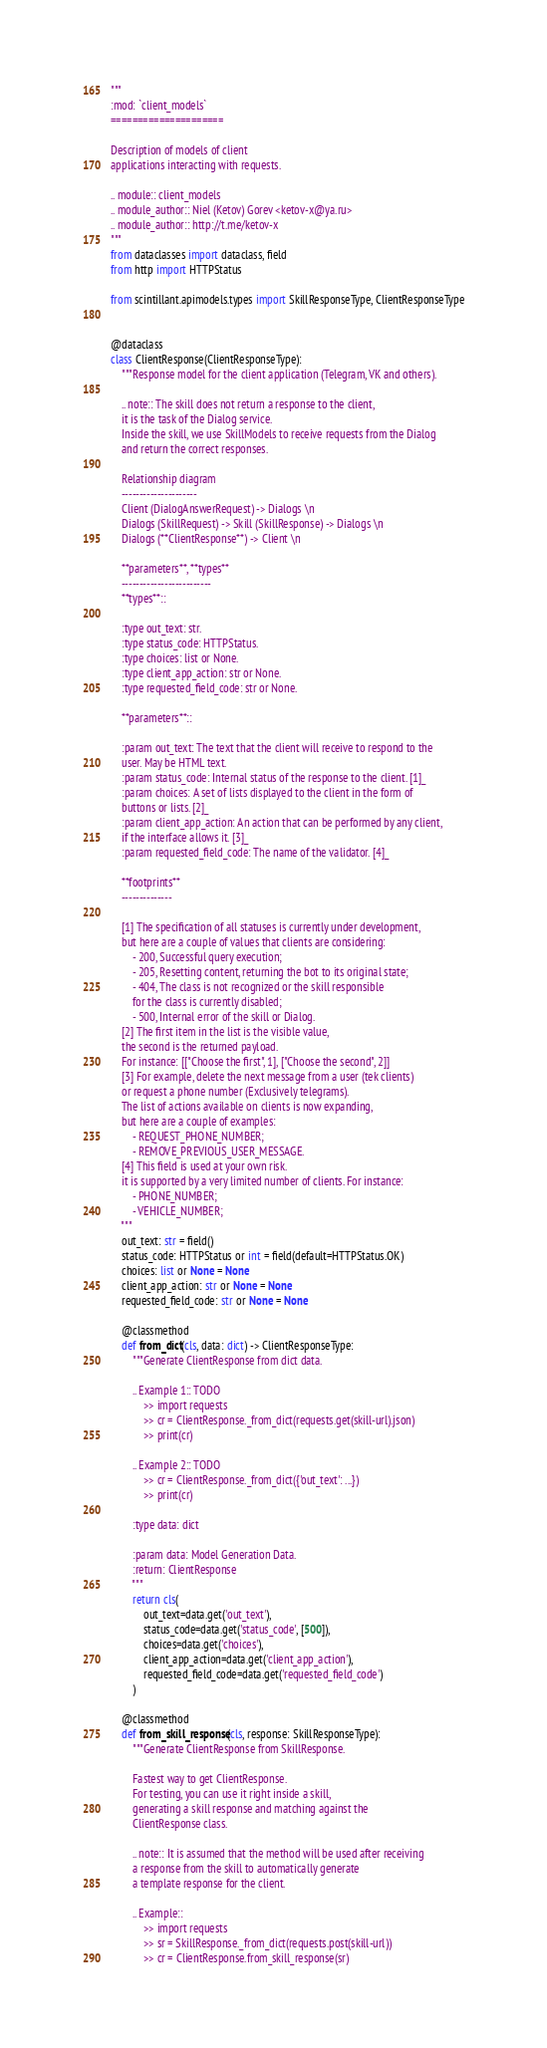Convert code to text. <code><loc_0><loc_0><loc_500><loc_500><_Python_>"""
:mod: `client_models`
=====================

Description of models of client
applications interacting with requests.

.. module:: client_models
.. module_author:: Niel (Ketov) Gorev <ketov-x@ya.ru>
.. module_author:: http://t.me/ketov-x
"""
from dataclasses import dataclass, field
from http import HTTPStatus

from scintillant.apimodels.types import SkillResponseType, ClientResponseType


@dataclass
class ClientResponse(ClientResponseType):
    """Response model for the client application (Telegram, VK and others).

    .. note:: The skill does not return a response to the client,
    it is the task of the Dialog service.
    Inside the skill, we use SkillModels to receive requests from the Dialog
    and return the correct responses.

    Relationship diagram
    ---------------------
    Client (DialogAnswerRequest) -> Dialogs \n
    Dialogs (SkillRequest) -> Skill (SkillResponse) -> Dialogs \n
    Dialogs (**ClientResponse**) -> Client \n

    **parameters**, **types**
    -------------------------
    **types**::

    :type out_text: str.
    :type status_code: HTTPStatus.
    :type choices: list or None.
    :type client_app_action: str or None.
    :type requested_field_code: str or None.

    **parameters**::

    :param out_text: The text that the client will receive to respond to the
    user. May be HTML text.
    :param status_code: Internal status of the response to the client. [1]_
    :param choices: A set of lists displayed to the client in the form of
    buttons or lists. [2]_
    :param client_app_action: An action that can be performed by any client,
    if the interface allows it. [3]_
    :param requested_field_code: The name of the validator. [4]_

    **footprints**
    --------------

    [1] The specification of all statuses is currently under development,
    but here are a couple of values that clients are considering:
        - 200, Successful query execution;
        - 205, Resetting content, returning the bot to its original state;
        - 404, The class is not recognized or the skill responsible
        for the class is currently disabled;
        - 500, Internal error of the skill or Dialog.
    [2] The first item in the list is the visible value,
    the second is the returned payload.
    For instance: [["Choose the first", 1], ["Choose the second", 2]]
    [3] For example, delete the next message from a user (tek clients)
    or request a phone number (Exclusively telegrams).
    The list of actions available on clients is now expanding,
    but here are a couple of examples:
        - REQUEST_PHONE_NUMBER;
        - REMOVE_PREVIOUS_USER_MESSAGE.
    [4] This field is used at your own risk.
    it is supported by a very limited number of clients. For instance:
        - PHONE_NUMBER;
        - VEHICLE_NUMBER;
    """
    out_text: str = field()
    status_code: HTTPStatus or int = field(default=HTTPStatus.OK)
    choices: list or None = None
    client_app_action: str or None = None
    requested_field_code: str or None = None

    @classmethod
    def from_dict(cls, data: dict) -> ClientResponseType:
        """Generate ClientResponse from dict data.

        .. Example 1:: TODO
            >> import requests
            >> cr = ClientResponse._from_dict(requests.get(skill-url).json)
            >> print(cr)

        .. Example 2:: TODO
            >> cr = ClientResponse._from_dict({'out_text': ...})
            >> print(cr)

        :type data: dict

        :param data: Model Generation Data.
        :return: ClientResponse
        """
        return cls(
            out_text=data.get('out_text'),
            status_code=data.get('status_code', [500]),
            choices=data.get('choices'),
            client_app_action=data.get('client_app_action'),
            requested_field_code=data.get('requested_field_code')
        )

    @classmethod
    def from_skill_response(cls, response: SkillResponseType):
        """Generate ClientResponse from SkillResponse.

        Fastest way to get ClientResponse.
        For testing, you can use it right inside a skill,
        generating a skill response and matching against the
        ClientResponse class.

        .. note:: It is assumed that the method will be used after receiving
        a response from the skill to automatically generate
        a template response for the client.

        .. Example::
            >> import requests
            >> sr = SkillResponse._from_dict(requests.post(skill-url))
            >> cr = ClientResponse.from_skill_response(sr)
</code> 